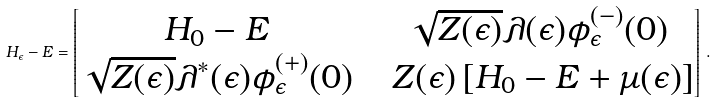Convert formula to latex. <formula><loc_0><loc_0><loc_500><loc_500>H _ { \epsilon } - E = \begin{bmatrix} H _ { 0 } - E & \ \sqrt { Z ( \epsilon ) } \lambda ( \epsilon ) \phi ^ { ( - ) } _ { \epsilon } ( 0 ) \\ \sqrt { Z ( \epsilon ) } \lambda ^ { \ast } ( \epsilon ) \phi ^ { ( + ) } _ { \epsilon } ( 0 ) & \ \ Z ( \epsilon ) \left [ H _ { 0 } - E + \mu ( \epsilon ) \right ] \\ \end{bmatrix} \, .</formula> 